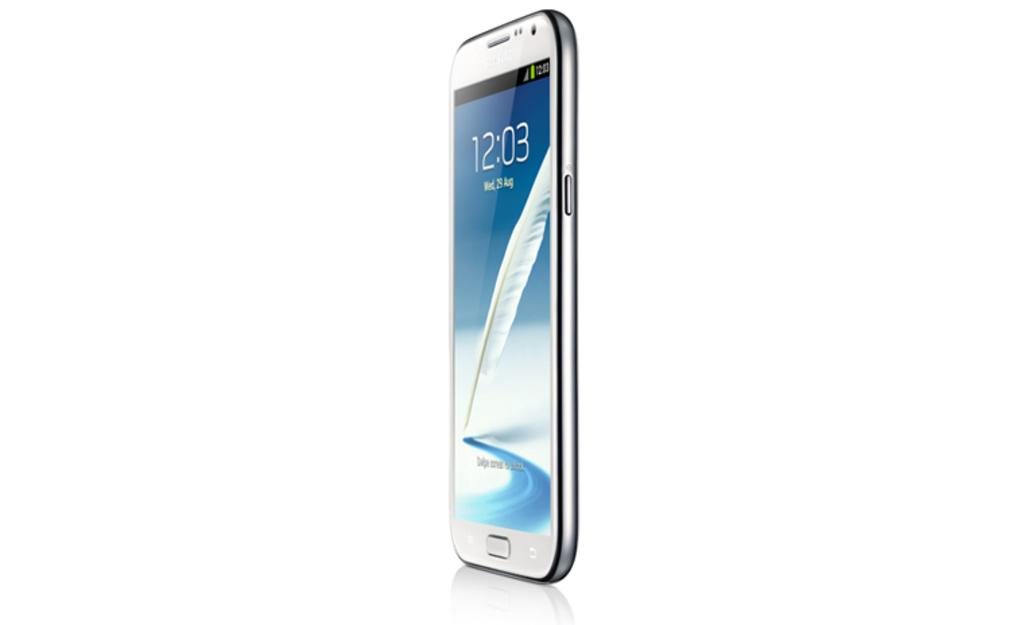<image>
Render a clear and concise summary of the photo. Wed August the 9th is written on the face of a silver cell phone. 